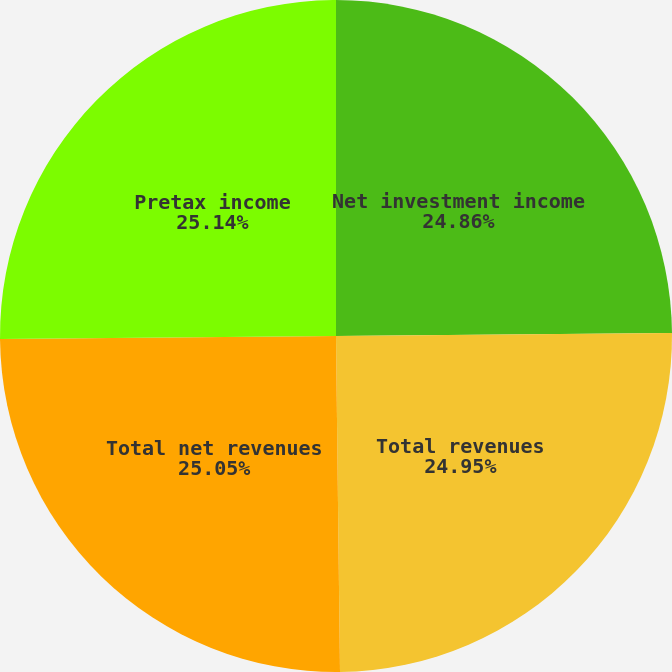Convert chart. <chart><loc_0><loc_0><loc_500><loc_500><pie_chart><fcel>Net investment income<fcel>Total revenues<fcel>Total net revenues<fcel>Pretax income<nl><fcel>24.86%<fcel>24.95%<fcel>25.05%<fcel>25.14%<nl></chart> 